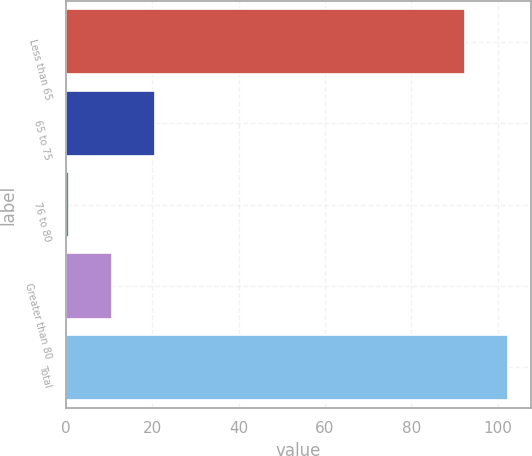Convert chart. <chart><loc_0><loc_0><loc_500><loc_500><bar_chart><fcel>Less than 65<fcel>65 to 75<fcel>76 to 80<fcel>Greater than 80<fcel>Total<nl><fcel>92.5<fcel>20.56<fcel>0.7<fcel>10.63<fcel>102.43<nl></chart> 